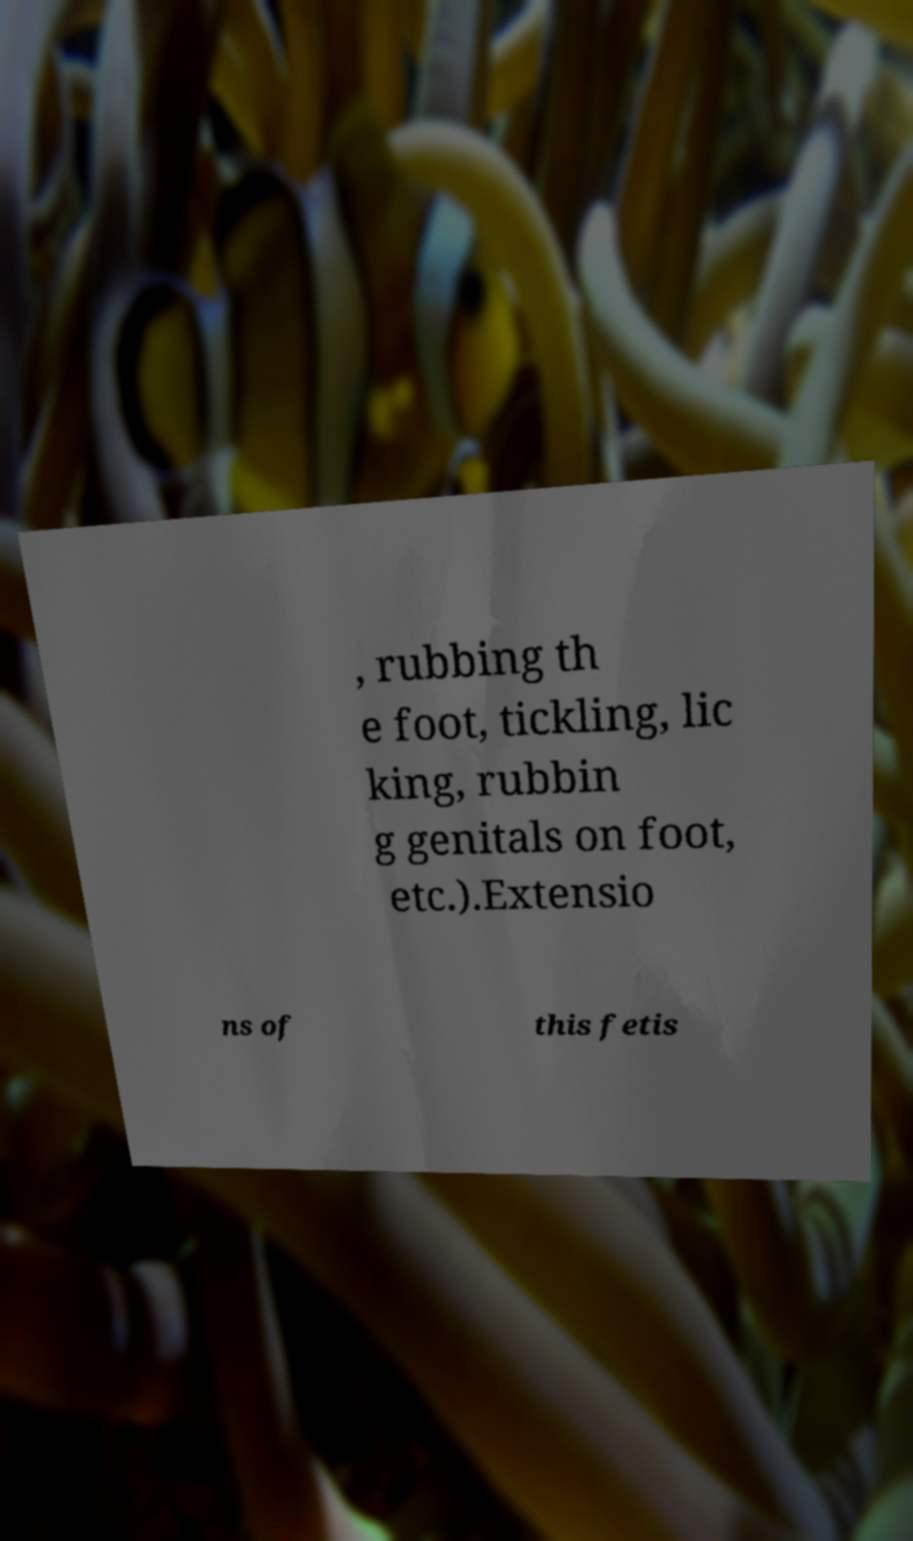I need the written content from this picture converted into text. Can you do that? , rubbing th e foot, tickling, lic king, rubbin g genitals on foot, etc.).Extensio ns of this fetis 